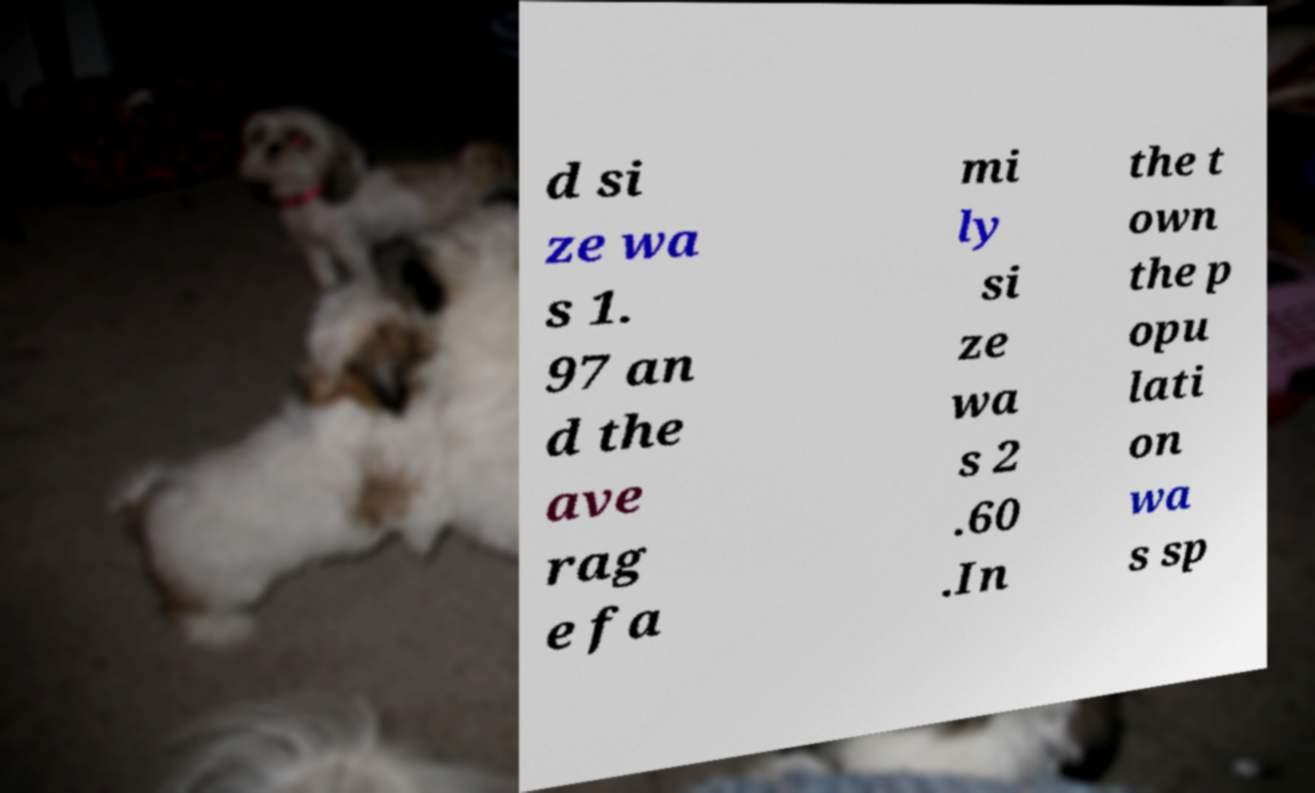Please identify and transcribe the text found in this image. d si ze wa s 1. 97 an d the ave rag e fa mi ly si ze wa s 2 .60 .In the t own the p opu lati on wa s sp 